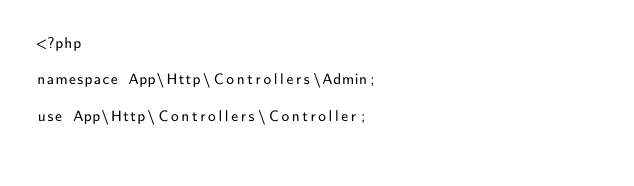Convert code to text. <code><loc_0><loc_0><loc_500><loc_500><_PHP_><?php

namespace App\Http\Controllers\Admin;

use App\Http\Controllers\Controller;</code> 